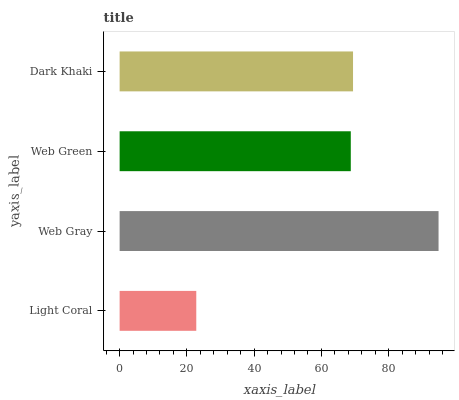Is Light Coral the minimum?
Answer yes or no. Yes. Is Web Gray the maximum?
Answer yes or no. Yes. Is Web Green the minimum?
Answer yes or no. No. Is Web Green the maximum?
Answer yes or no. No. Is Web Gray greater than Web Green?
Answer yes or no. Yes. Is Web Green less than Web Gray?
Answer yes or no. Yes. Is Web Green greater than Web Gray?
Answer yes or no. No. Is Web Gray less than Web Green?
Answer yes or no. No. Is Dark Khaki the high median?
Answer yes or no. Yes. Is Web Green the low median?
Answer yes or no. Yes. Is Web Green the high median?
Answer yes or no. No. Is Light Coral the low median?
Answer yes or no. No. 